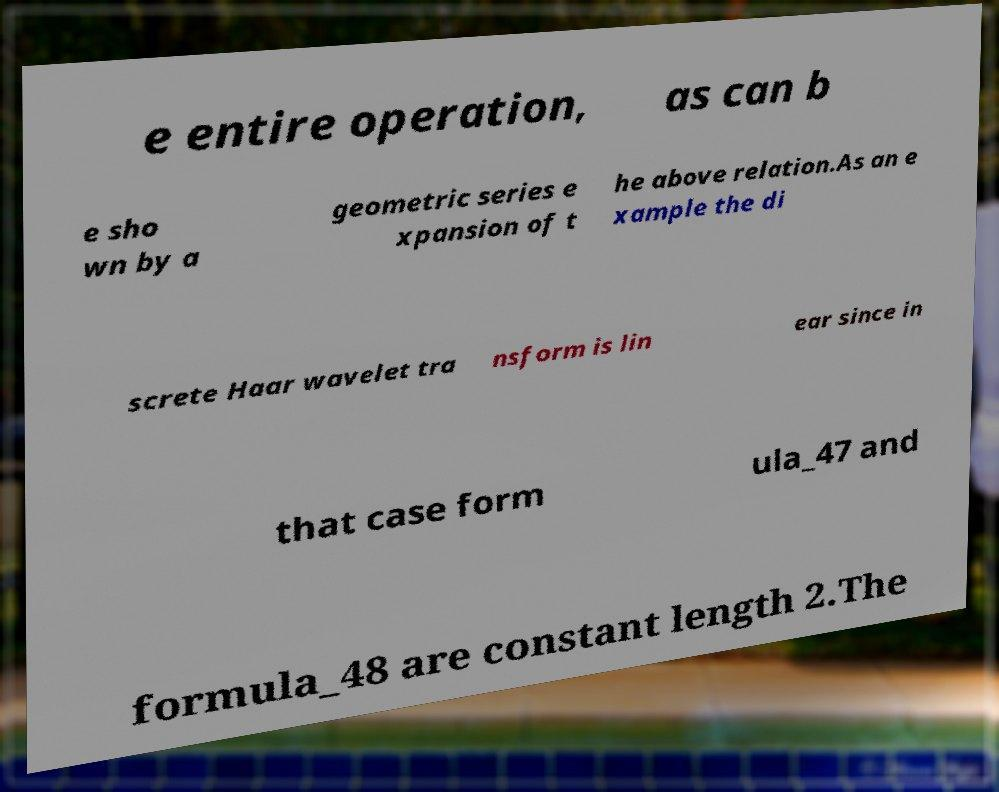I need the written content from this picture converted into text. Can you do that? e entire operation, as can b e sho wn by a geometric series e xpansion of t he above relation.As an e xample the di screte Haar wavelet tra nsform is lin ear since in that case form ula_47 and formula_48 are constant length 2.The 